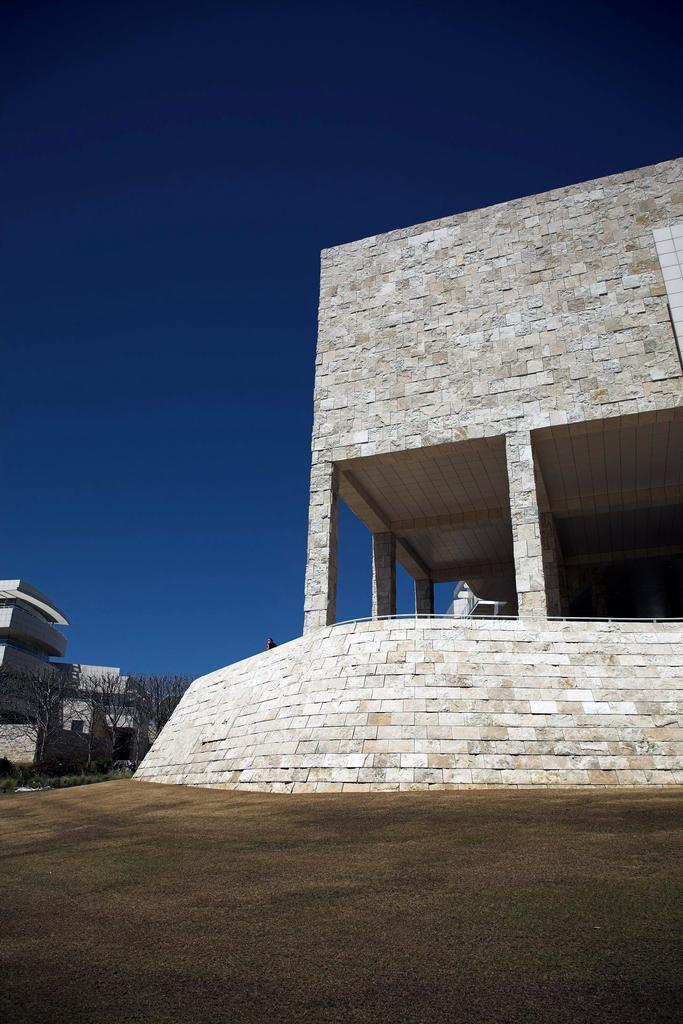What type of structure is present in the image? There is a building in the image. Can you describe the interior of the building? There is a person and a table inside the building. What is visible at the top of the image? The sky is visible at the top of the image. What can be seen on the left side of the image? There are buildings and trees visible on the left side of the image. How many geese are grazing in the field on the right side of the image? There is no field or geese present in the image. What type of duck can be seen swimming in the pond on the left side of the image? There is no pond or duck present in the image. 